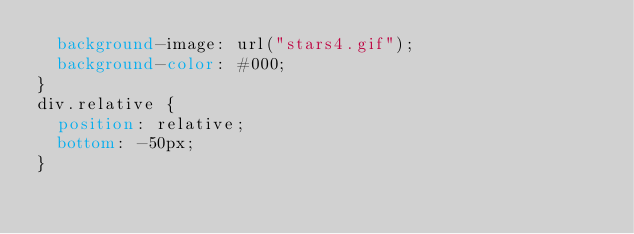<code> <loc_0><loc_0><loc_500><loc_500><_CSS_>  background-image: url("stars4.gif");
  background-color: #000;
}
div.relative {
  position: relative;
  bottom: -50px;
}

</code> 